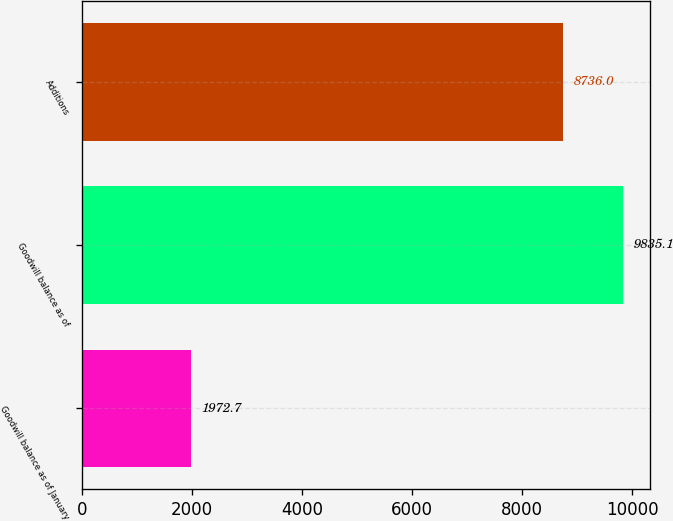Convert chart to OTSL. <chart><loc_0><loc_0><loc_500><loc_500><bar_chart><fcel>Goodwill balance as of January<fcel>Goodwill balance as of<fcel>Additions<nl><fcel>1972.7<fcel>9835.1<fcel>8736<nl></chart> 